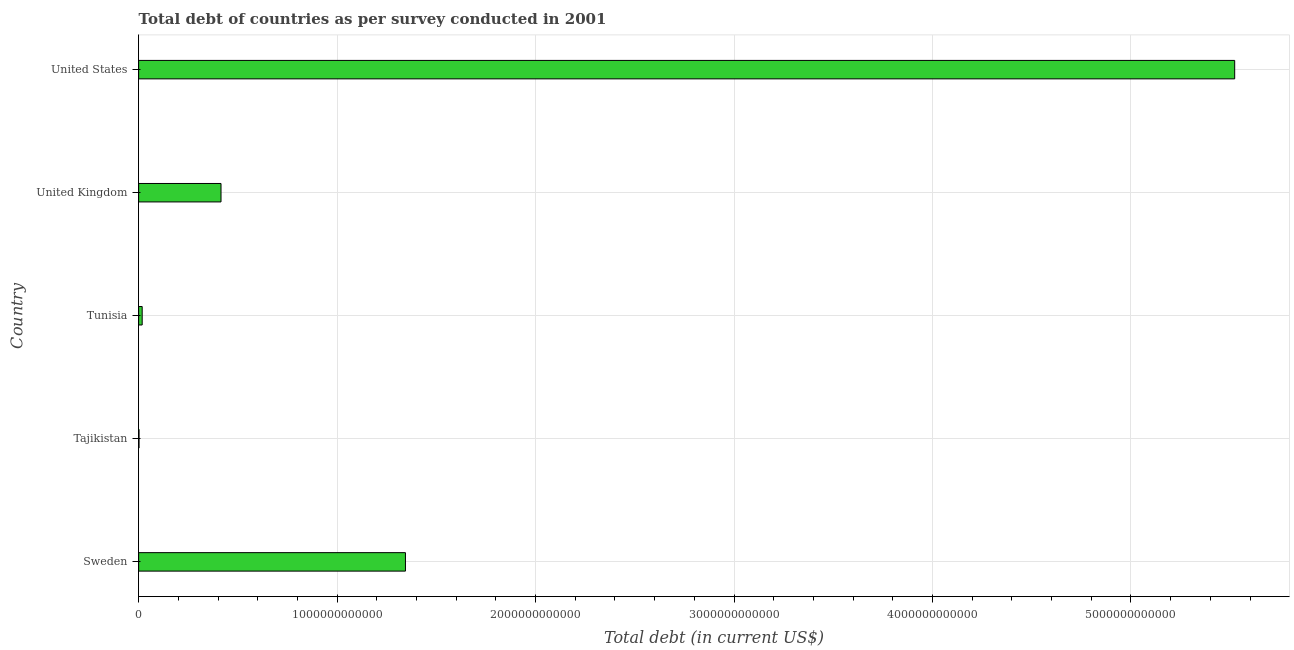Does the graph contain any zero values?
Your answer should be compact. No. Does the graph contain grids?
Make the answer very short. Yes. What is the title of the graph?
Keep it short and to the point. Total debt of countries as per survey conducted in 2001. What is the label or title of the X-axis?
Ensure brevity in your answer.  Total debt (in current US$). What is the label or title of the Y-axis?
Provide a succinct answer. Country. What is the total debt in United Kingdom?
Ensure brevity in your answer.  4.15e+11. Across all countries, what is the maximum total debt?
Make the answer very short. 5.52e+12. Across all countries, what is the minimum total debt?
Your answer should be compact. 2.05e+09. In which country was the total debt maximum?
Your answer should be very brief. United States. In which country was the total debt minimum?
Keep it short and to the point. Tajikistan. What is the sum of the total debt?
Offer a terse response. 7.30e+12. What is the difference between the total debt in Sweden and United Kingdom?
Ensure brevity in your answer.  9.29e+11. What is the average total debt per country?
Provide a succinct answer. 1.46e+12. What is the median total debt?
Your answer should be compact. 4.15e+11. What is the ratio of the total debt in Tunisia to that in United Kingdom?
Your answer should be compact. 0.04. What is the difference between the highest and the second highest total debt?
Offer a very short reply. 4.18e+12. Is the sum of the total debt in Tajikistan and United Kingdom greater than the maximum total debt across all countries?
Ensure brevity in your answer.  No. What is the difference between the highest and the lowest total debt?
Your answer should be compact. 5.52e+12. In how many countries, is the total debt greater than the average total debt taken over all countries?
Offer a terse response. 1. How many bars are there?
Give a very brief answer. 5. What is the difference between two consecutive major ticks on the X-axis?
Ensure brevity in your answer.  1.00e+12. Are the values on the major ticks of X-axis written in scientific E-notation?
Give a very brief answer. No. What is the Total debt (in current US$) in Sweden?
Provide a short and direct response. 1.34e+12. What is the Total debt (in current US$) of Tajikistan?
Your response must be concise. 2.05e+09. What is the Total debt (in current US$) of Tunisia?
Your answer should be very brief. 1.79e+1. What is the Total debt (in current US$) in United Kingdom?
Give a very brief answer. 4.15e+11. What is the Total debt (in current US$) of United States?
Your answer should be very brief. 5.52e+12. What is the difference between the Total debt (in current US$) in Sweden and Tajikistan?
Ensure brevity in your answer.  1.34e+12. What is the difference between the Total debt (in current US$) in Sweden and Tunisia?
Offer a terse response. 1.33e+12. What is the difference between the Total debt (in current US$) in Sweden and United Kingdom?
Keep it short and to the point. 9.29e+11. What is the difference between the Total debt (in current US$) in Sweden and United States?
Keep it short and to the point. -4.18e+12. What is the difference between the Total debt (in current US$) in Tajikistan and Tunisia?
Provide a succinct answer. -1.59e+1. What is the difference between the Total debt (in current US$) in Tajikistan and United Kingdom?
Provide a succinct answer. -4.13e+11. What is the difference between the Total debt (in current US$) in Tajikistan and United States?
Give a very brief answer. -5.52e+12. What is the difference between the Total debt (in current US$) in Tunisia and United Kingdom?
Your answer should be compact. -3.97e+11. What is the difference between the Total debt (in current US$) in Tunisia and United States?
Your answer should be very brief. -5.50e+12. What is the difference between the Total debt (in current US$) in United Kingdom and United States?
Your response must be concise. -5.11e+12. What is the ratio of the Total debt (in current US$) in Sweden to that in Tajikistan?
Provide a short and direct response. 657.09. What is the ratio of the Total debt (in current US$) in Sweden to that in Tunisia?
Ensure brevity in your answer.  75. What is the ratio of the Total debt (in current US$) in Sweden to that in United Kingdom?
Offer a terse response. 3.24. What is the ratio of the Total debt (in current US$) in Sweden to that in United States?
Provide a succinct answer. 0.24. What is the ratio of the Total debt (in current US$) in Tajikistan to that in Tunisia?
Your answer should be very brief. 0.11. What is the ratio of the Total debt (in current US$) in Tajikistan to that in United Kingdom?
Offer a very short reply. 0.01. What is the ratio of the Total debt (in current US$) in Tunisia to that in United Kingdom?
Give a very brief answer. 0.04. What is the ratio of the Total debt (in current US$) in Tunisia to that in United States?
Provide a succinct answer. 0. What is the ratio of the Total debt (in current US$) in United Kingdom to that in United States?
Ensure brevity in your answer.  0.07. 